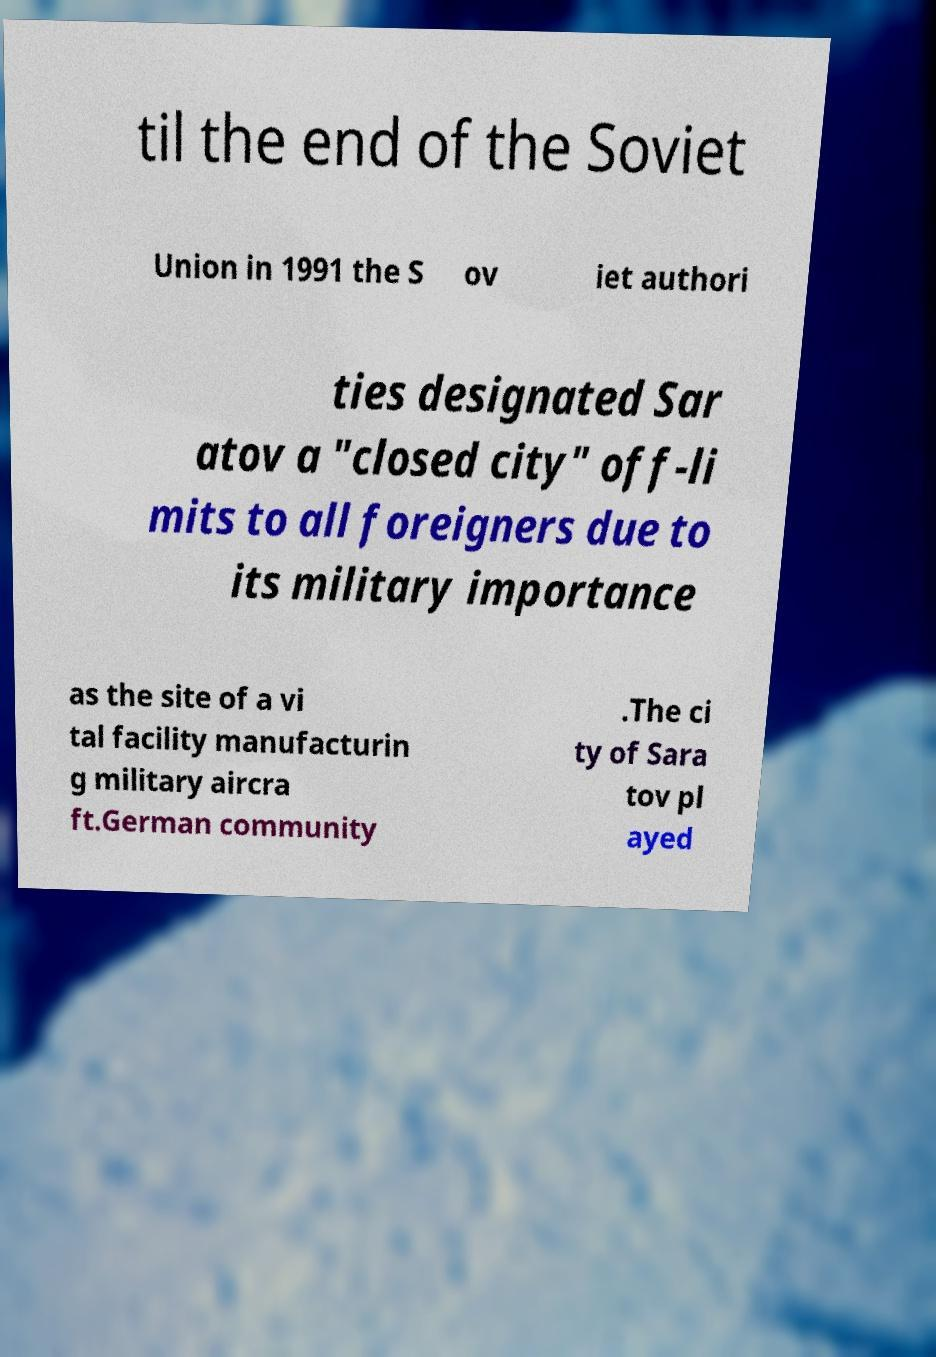What messages or text are displayed in this image? I need them in a readable, typed format. til the end of the Soviet Union in 1991 the S ov iet authori ties designated Sar atov a "closed city" off-li mits to all foreigners due to its military importance as the site of a vi tal facility manufacturin g military aircra ft.German community .The ci ty of Sara tov pl ayed 